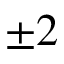<formula> <loc_0><loc_0><loc_500><loc_500>\pm 2</formula> 